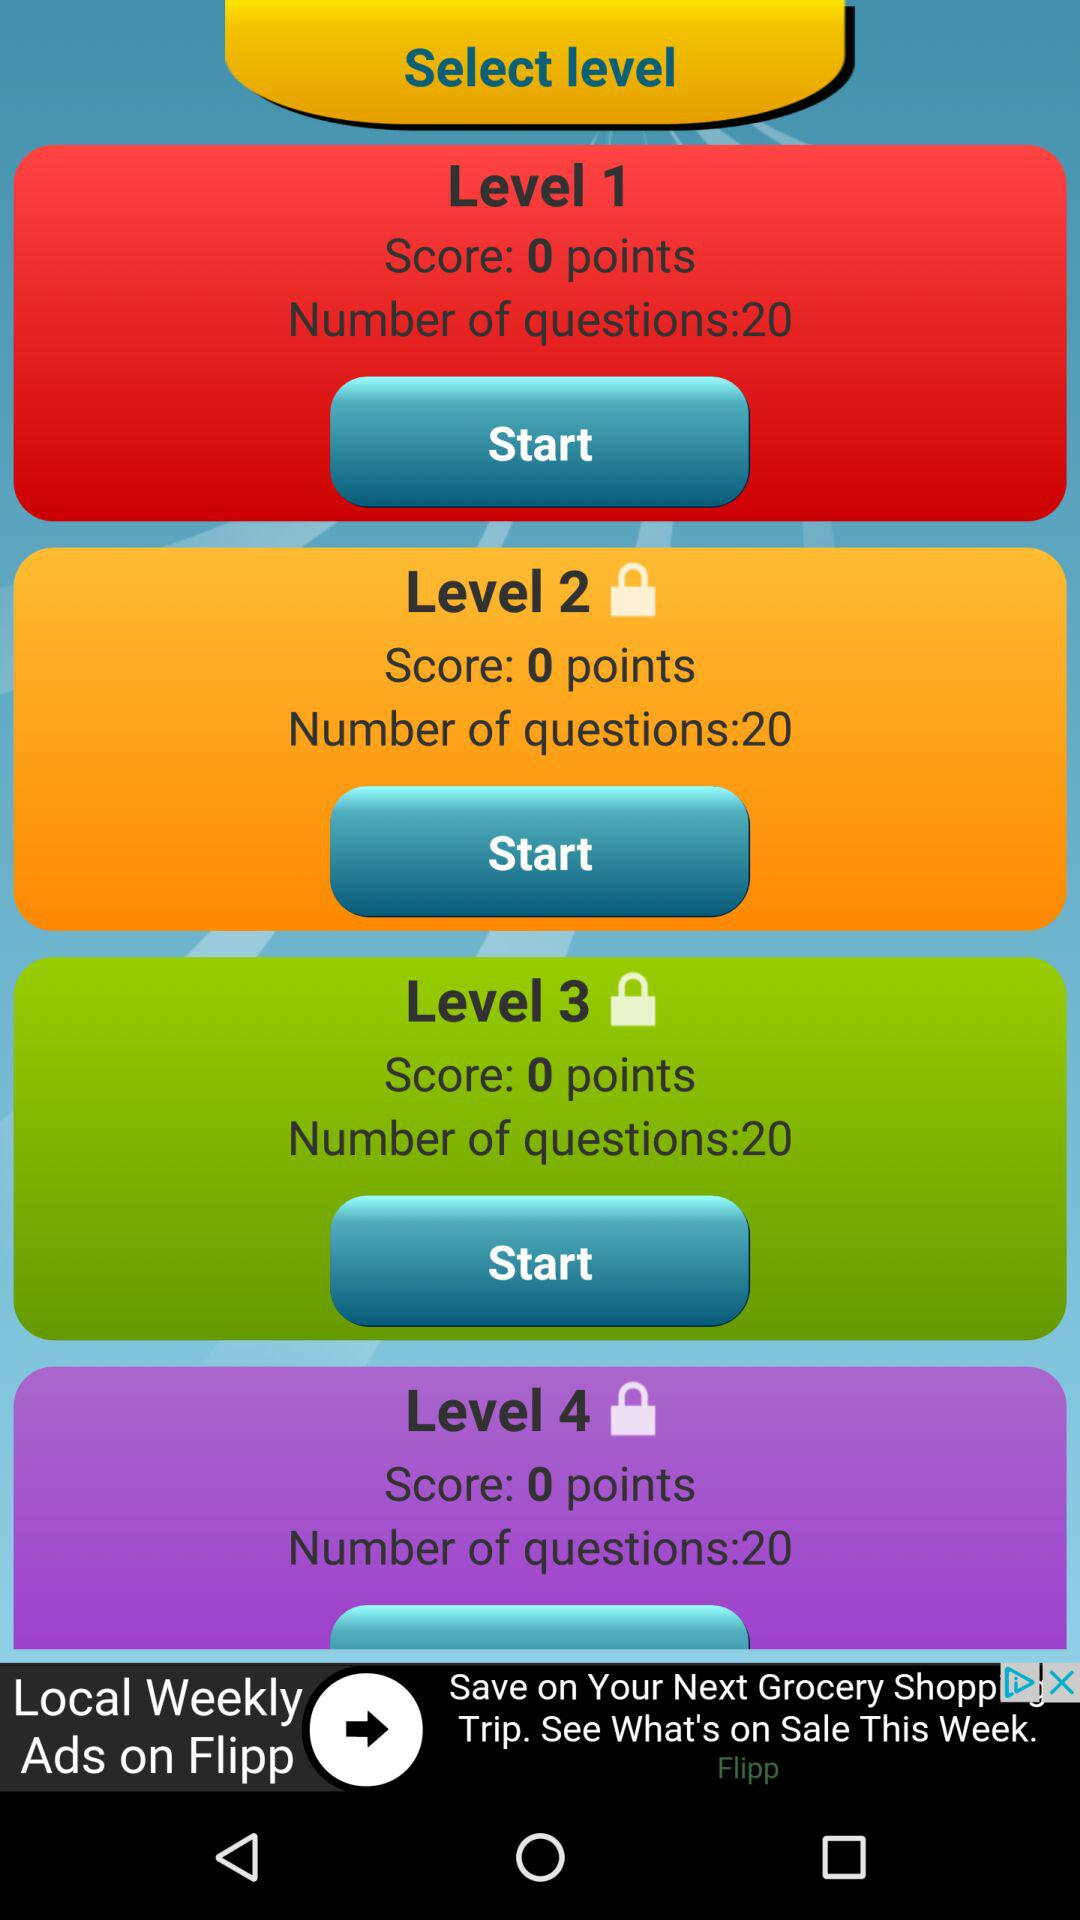How well does level two rate?
When the provided information is insufficient, respond with <no answer>. <no answer> 